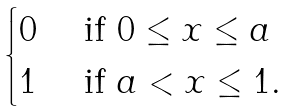<formula> <loc_0><loc_0><loc_500><loc_500>\begin{cases} 0 & \text { if } 0 \leq x \leq a \\ 1 & \text { if } a < x \leq 1 . \end{cases}</formula> 